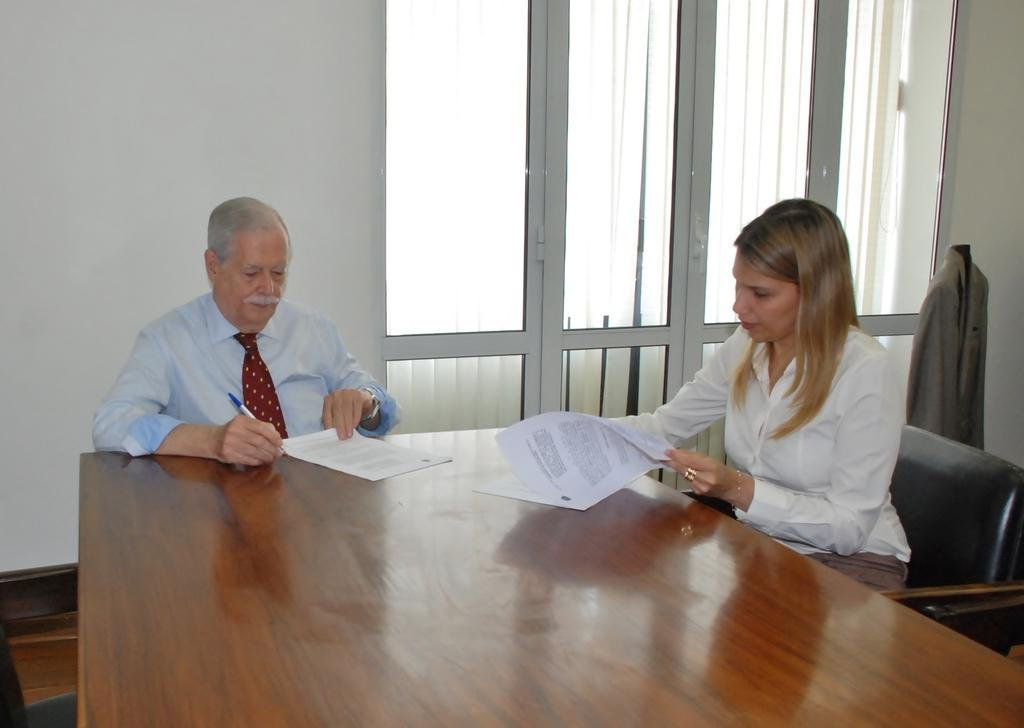How many people are in the image? There are two persons in the image. What are the persons doing in the image? The persons are sitting on chairs. Where are the chairs located in relation to each other? The chairs are around a table. What can be seen in the background of the image? There is a window and a wall in the background of the image. What type of map is on the table in the image? There is no map present in the image; it only shows two persons sitting on chairs around a table with a background of a window and a wall. 